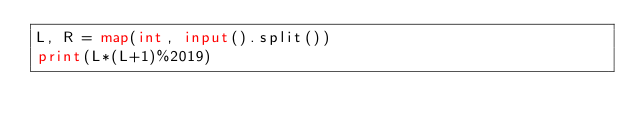<code> <loc_0><loc_0><loc_500><loc_500><_Python_>L, R = map(int, input().split())
print(L*(L+1)%2019)</code> 